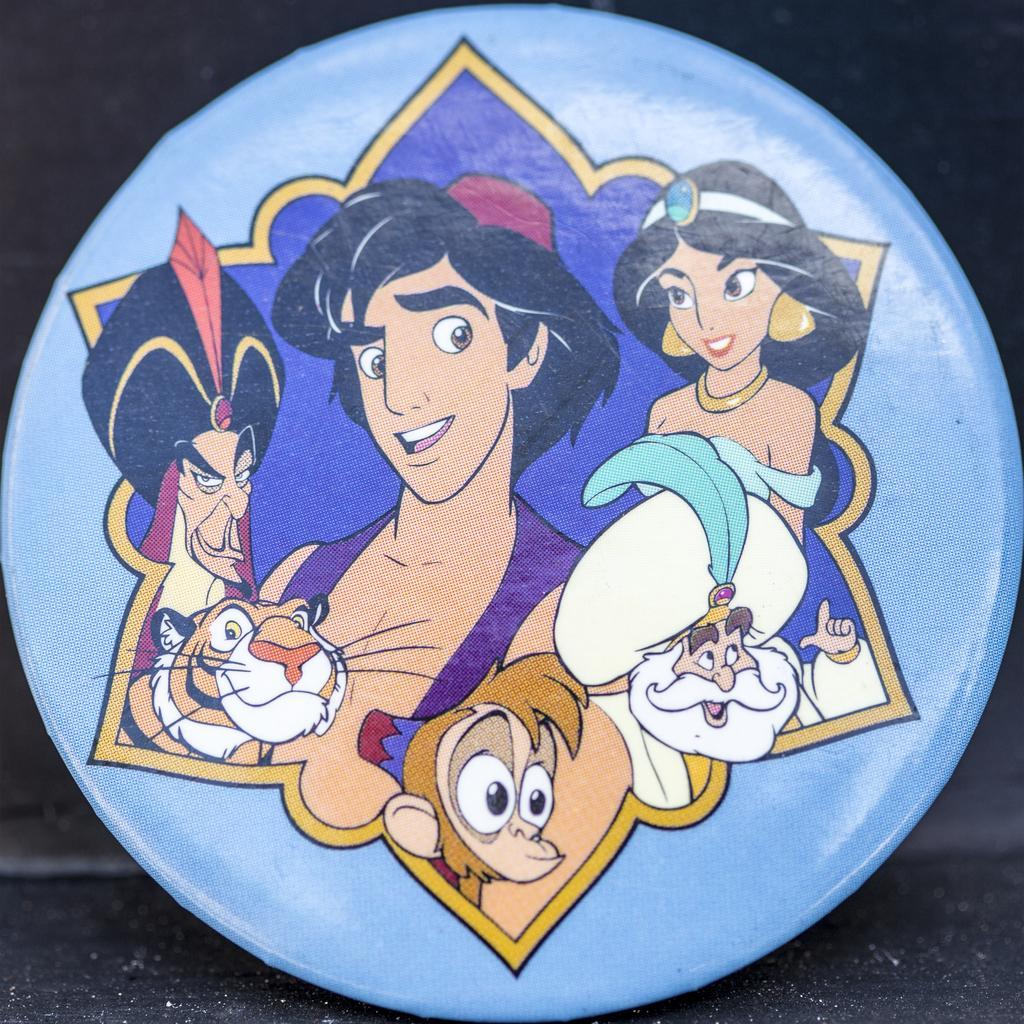Please provide a concise description of this image. In the given picture, we can see the floor and there is a small circle shape frame on which, we can see a few cartoon pictures on it. 